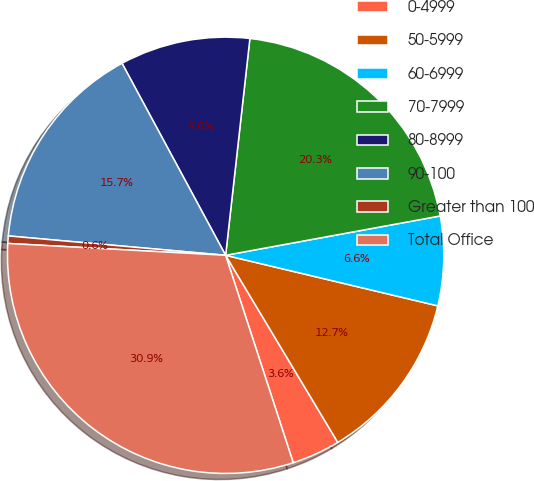<chart> <loc_0><loc_0><loc_500><loc_500><pie_chart><fcel>0-4999<fcel>50-5999<fcel>60-6999<fcel>70-7999<fcel>80-8999<fcel>90-100<fcel>Greater than 100<fcel>Total Office<nl><fcel>3.58%<fcel>12.68%<fcel>6.61%<fcel>20.34%<fcel>9.65%<fcel>15.71%<fcel>0.55%<fcel>30.88%<nl></chart> 